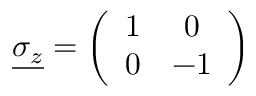<formula> <loc_0><loc_0><loc_500><loc_500>\underline { { { \sigma _ { z } } } } = \left ( \begin{array} { c c } { 1 } & { 0 } \\ { 0 } & { - 1 } \end{array} \right )</formula> 